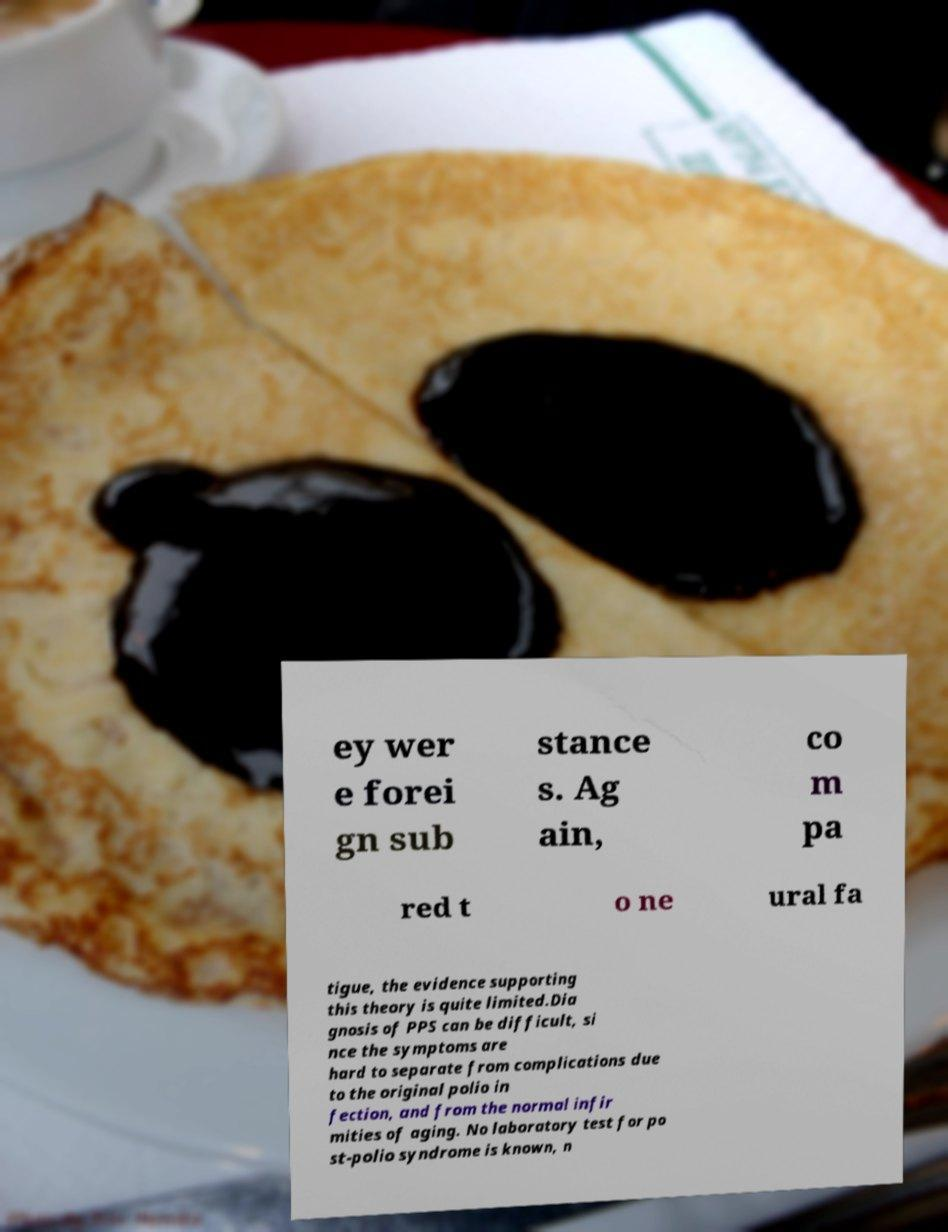Please identify and transcribe the text found in this image. ey wer e forei gn sub stance s. Ag ain, co m pa red t o ne ural fa tigue, the evidence supporting this theory is quite limited.Dia gnosis of PPS can be difficult, si nce the symptoms are hard to separate from complications due to the original polio in fection, and from the normal infir mities of aging. No laboratory test for po st-polio syndrome is known, n 